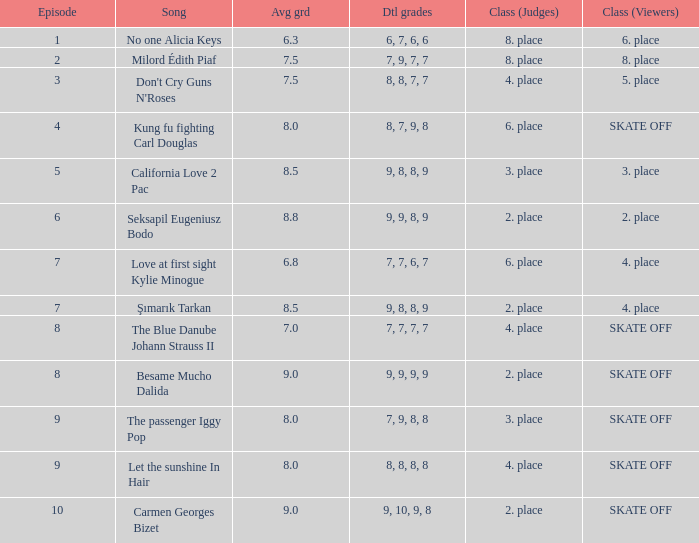Name the average grade for şımarık tarkan 8.5. 